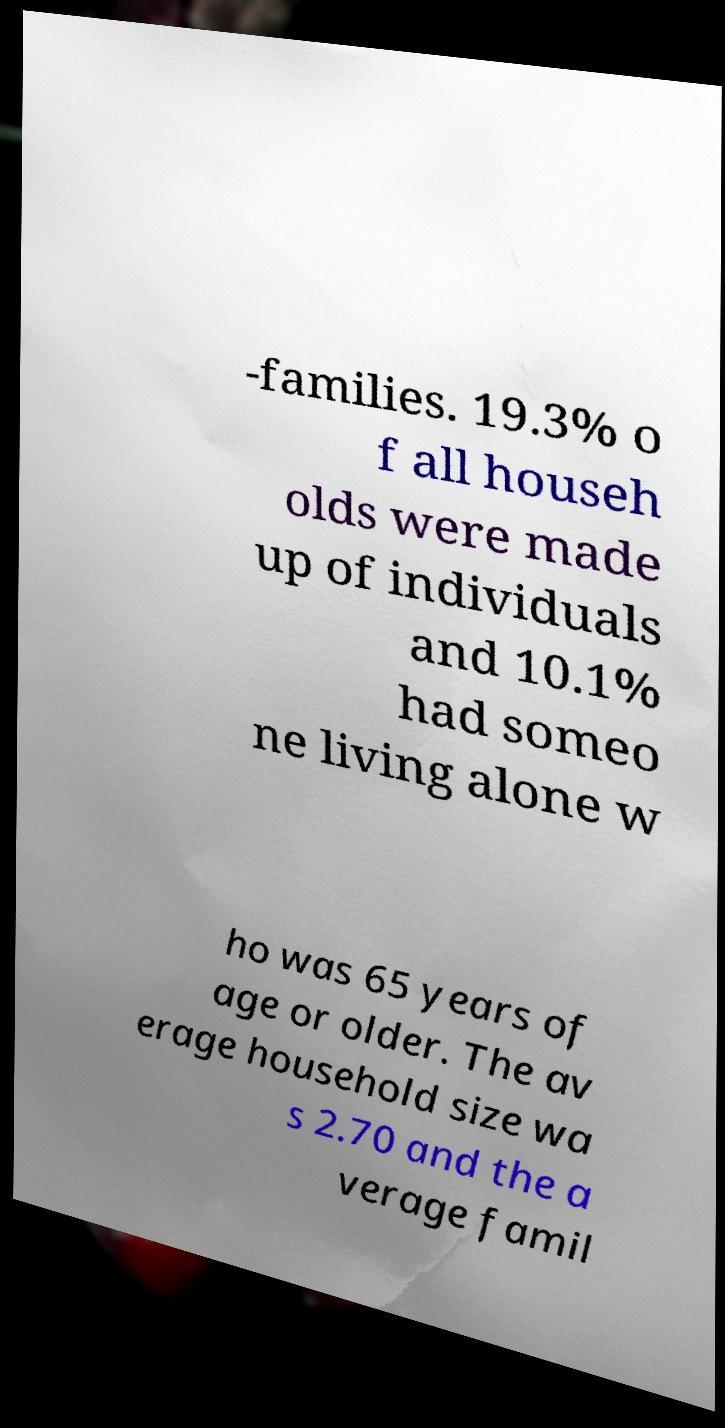Please identify and transcribe the text found in this image. -families. 19.3% o f all househ olds were made up of individuals and 10.1% had someo ne living alone w ho was 65 years of age or older. The av erage household size wa s 2.70 and the a verage famil 